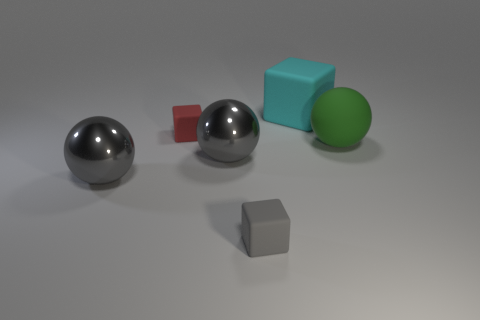Add 1 small red blocks. How many objects exist? 7 Add 4 small gray rubber objects. How many small gray rubber objects exist? 5 Subtract 0 yellow cylinders. How many objects are left? 6 Subtract all small purple shiny blocks. Subtract all cyan blocks. How many objects are left? 5 Add 5 metallic objects. How many metallic objects are left? 7 